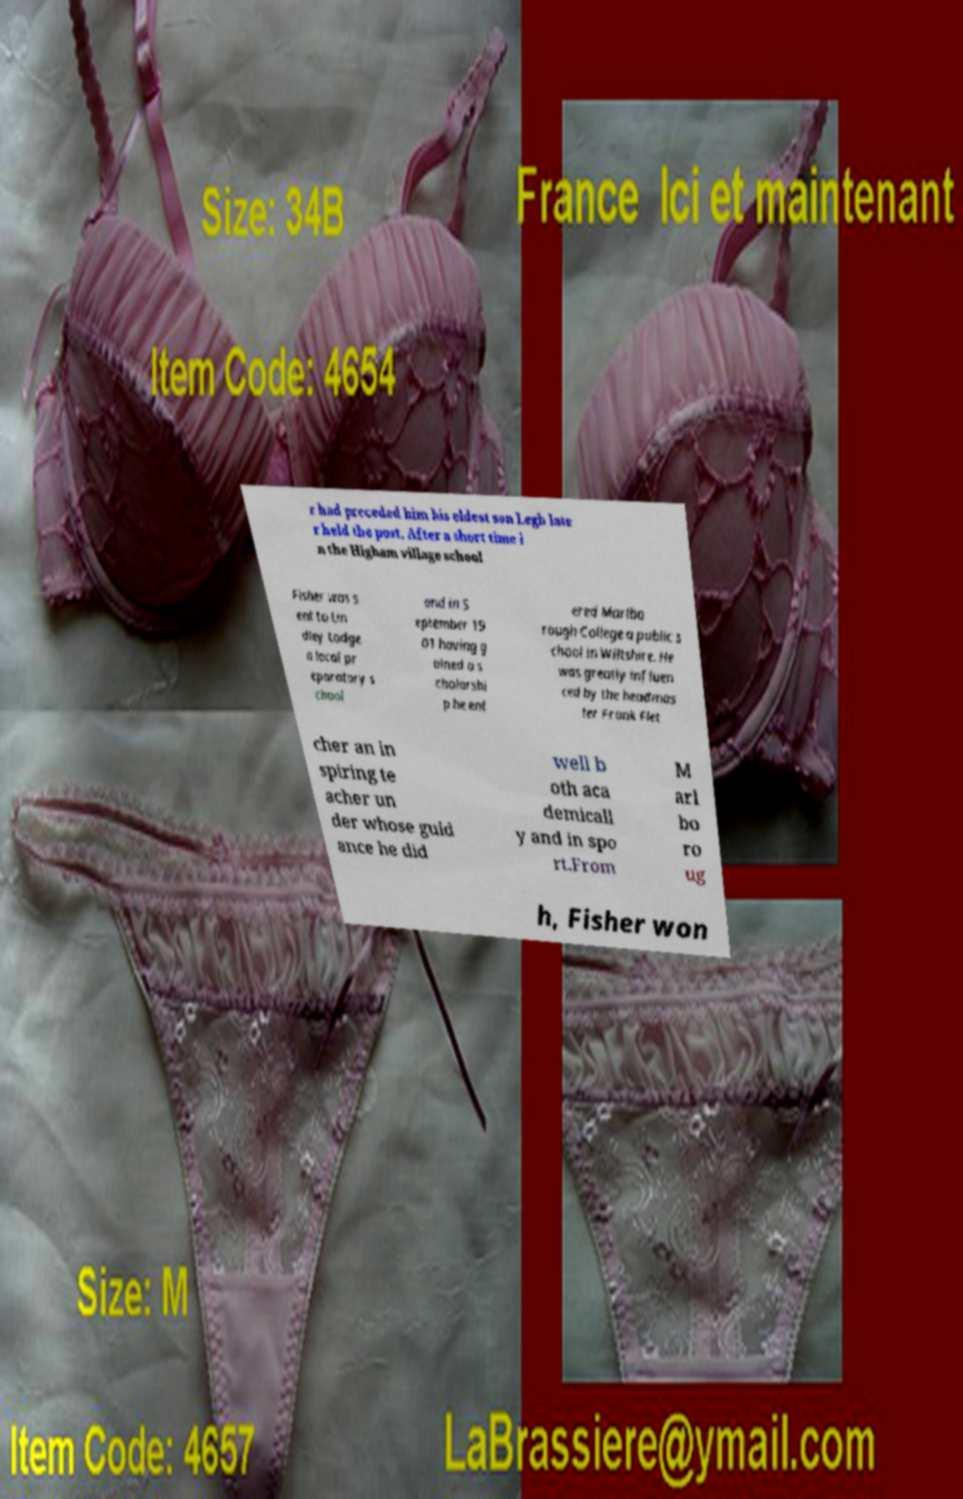Could you assist in decoding the text presented in this image and type it out clearly? r had preceded him his eldest son Legh late r held the post. After a short time i n the Higham village school Fisher was s ent to Lin dley Lodge a local pr eparatory s chool and in S eptember 19 01 having g ained a s cholarshi p he ent ered Marlbo rough College a public s chool in Wiltshire. He was greatly influen ced by the headmas ter Frank Flet cher an in spiring te acher un der whose guid ance he did well b oth aca demicall y and in spo rt.From M arl bo ro ug h, Fisher won 